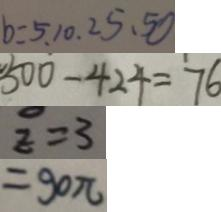Convert formula to latex. <formula><loc_0><loc_0><loc_500><loc_500>b : 5 . 1 0 . 2 5 . 5 0 
 5 0 0 - 4 2 4 = 7 6 
 z = 3 
 = 9 0 \pi</formula> 